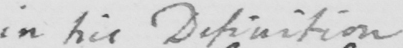What text is written in this handwritten line? in his Definition 